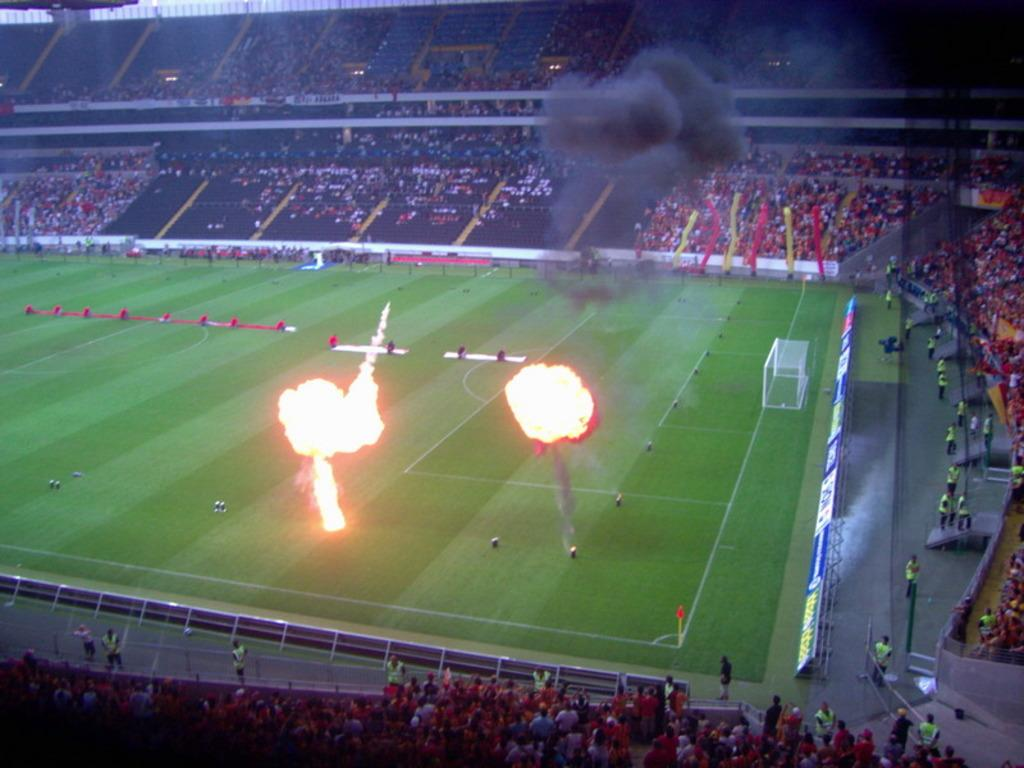What is happening in the middle of the playground in the image? There is fire in the middle of the playground. Where are the people located in the image? The people are in the stadium. What type of harbor can be seen in the image? There is no harbor present in the image; it features a playground with fire and a stadium with many people. How does the fire sort the people in the stadium? The fire does not sort the people in the stadium; it is an unrelated event happening in the playground. 